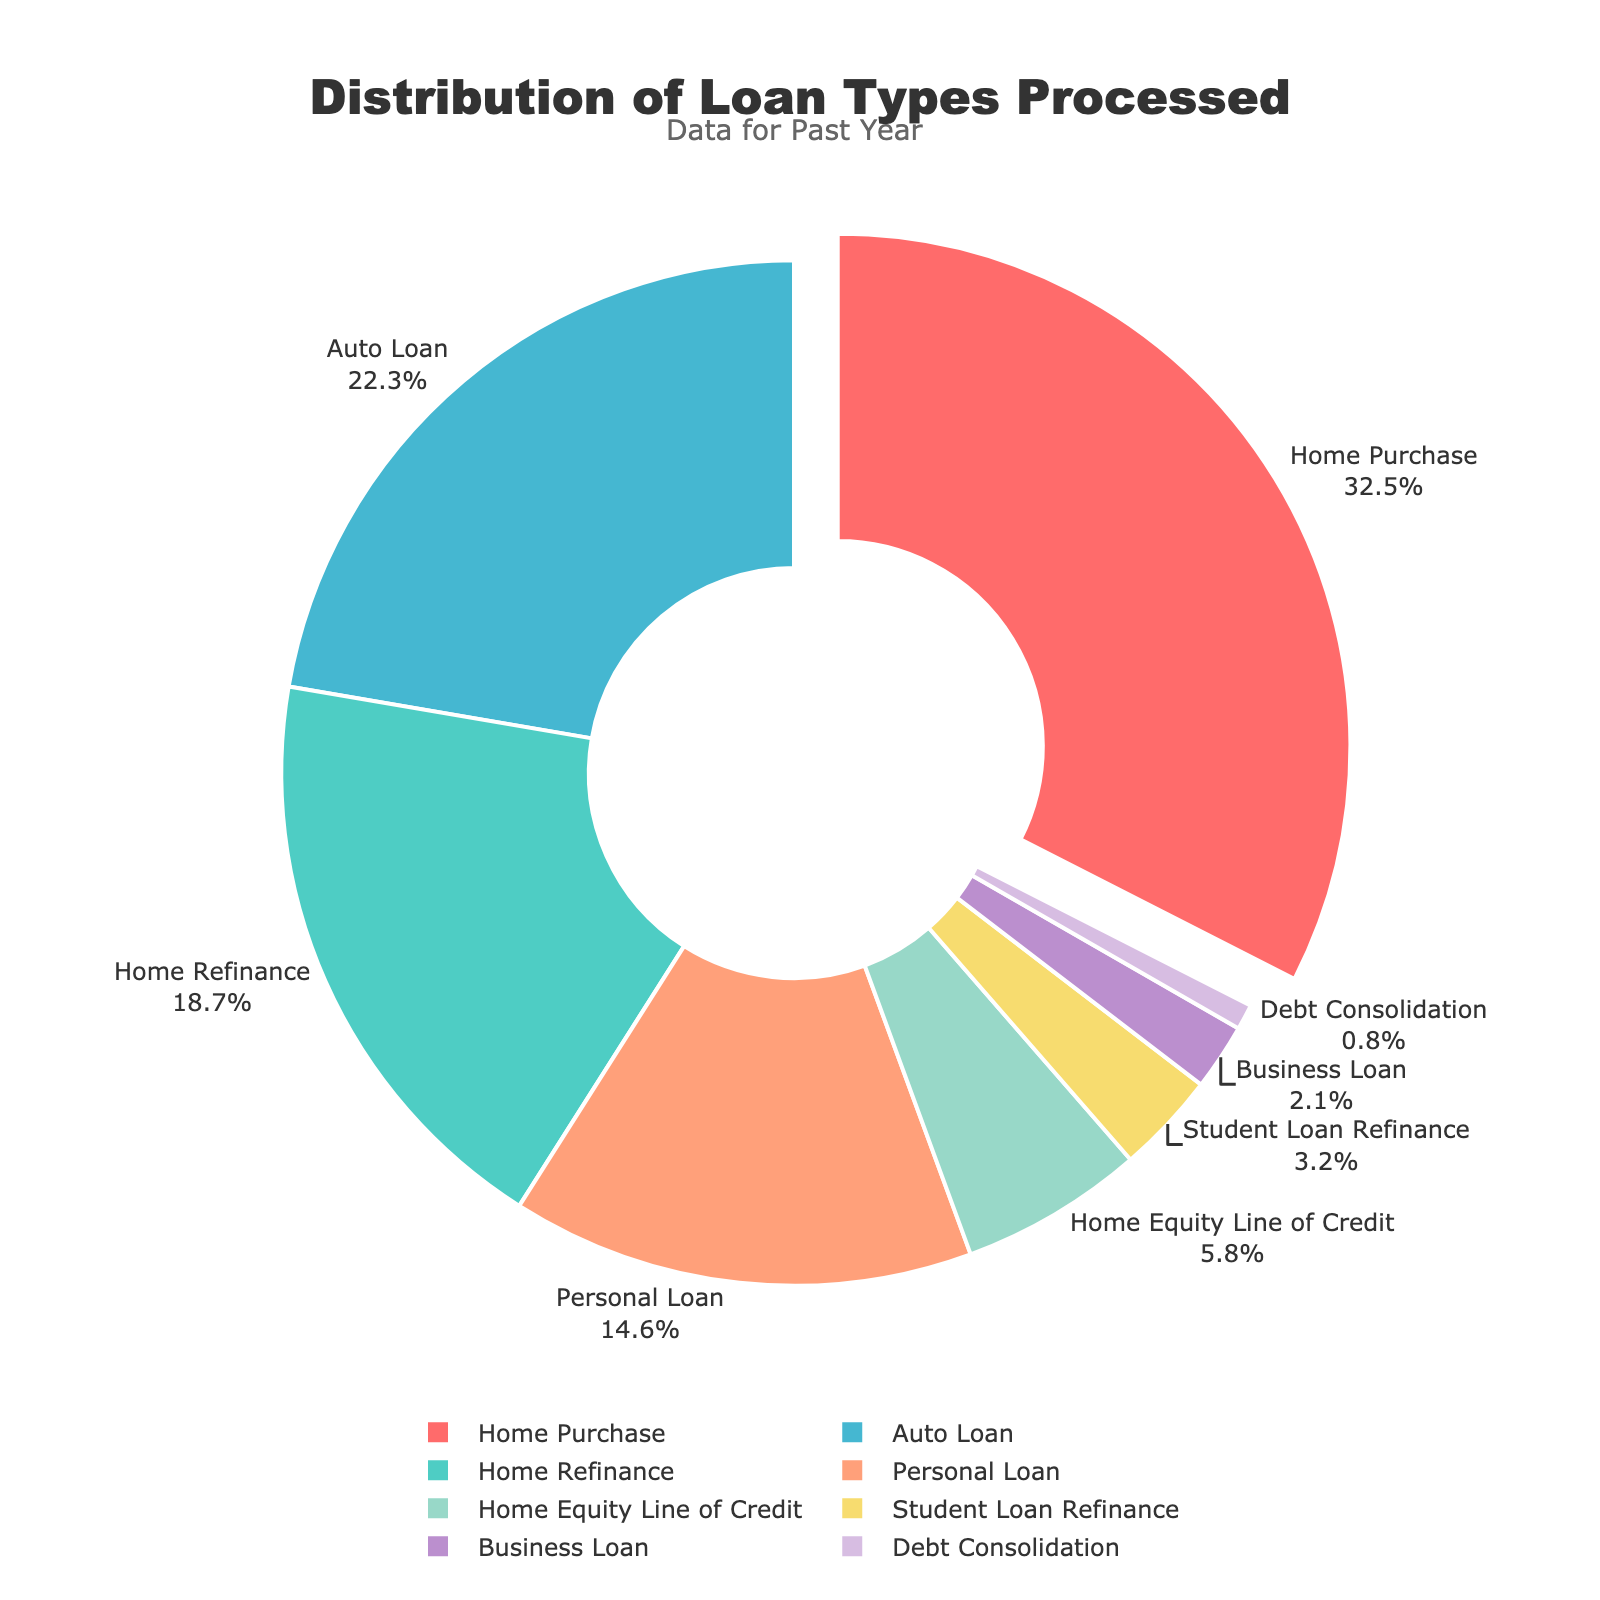What is the most common type of loan processed? The pie chart highlights the "Home Purchase" loan type by pulling it out slightly from the pie, indicating it has the highest percentage.
Answer: Home Purchase What percentage of loans processed were for home-related purposes (Home Purchase, Home Refinance, Home Equity Line of Credit)? Add the percentages for Home Purchase (32.5%), Home Refinance (18.7%), and Home Equity Line of Credit (5.8%) to get the total. 32.5 + 18.7 + 5.8 = 57.0%
Answer: 57.0% Which category accounts for a larger percentage: Auto Loan or Personal Loan? Compare the percentages directly from the chart: Auto Loan (22.3%) and Personal Loan (14.6%). Auto Loan has a higher percentage.
Answer: Auto Loan How much more common are Business Loans compared to Debt Consolidation loans? Subtract the percentage of Debt Consolidation (0.8%) from Business Loan (2.1%): 2.1 - 0.8 = 1.3%
Answer: 1.3% What is the least processed loan type? The smallest segment in the pie chart represents the Debt Consolidation loan type, with 0.8%.
Answer: Debt Consolidation Compare the combined percentage of Student Loan Refinance and Business Loan to the percentage of Personal Loan. Which is higher? Add the percentages for Student Loan Refinance (3.2%) and Business Loan (2.1%), then compare to Personal Loan (14.6%). 3.2 + 2.1 = 5.3%, which is less than 14.6%.
Answer: Personal Loan What is the combined percentage of Auto Loan and Personal Loan processed? Add the percentages for Auto Loan (22.3%) and Personal Loan (14.6%). 22.3 + 14.6 = 36.9%
Answer: 36.9% Are there more Home Refinance loans processed compared to all non-home related loans combined? Add up all non-home related loan percentages: Auto Loan (22.3%), Personal Loan (14.6%), Student Loan Refinance (3.2%), Business Loan (2.1%), Debt Consolidation (0.8%). The total is 22.3 + 14.6 + 3.2 + 2.1 + 0.8 = 43.0%. Compared to Home Refinance (18.7%), non-home related loans are more.
Answer: No 